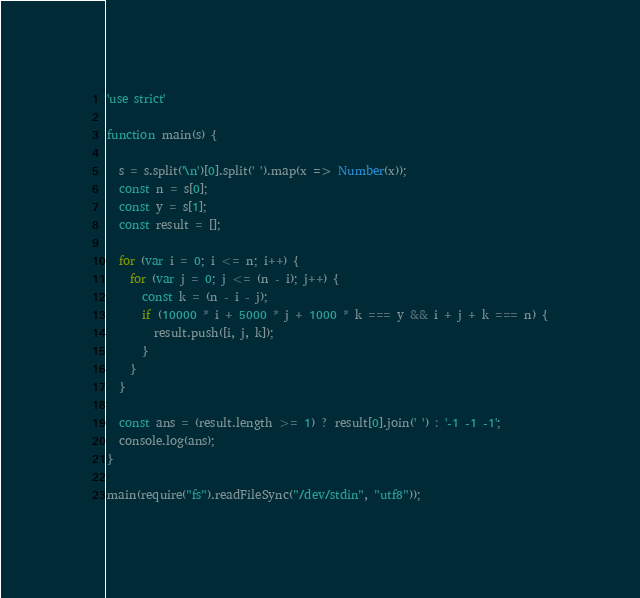<code> <loc_0><loc_0><loc_500><loc_500><_JavaScript_>'use strict'

function main(s) {

  s = s.split('\n')[0].split(' ').map(x => Number(x));
  const n = s[0];
  const y = s[1];
  const result = [];

  for (var i = 0; i <= n; i++) {
    for (var j = 0; j <= (n - i); j++) {
      const k = (n - i - j);
      if (10000 * i + 5000 * j + 1000 * k === y && i + j + k === n) {
        result.push([i, j, k]);
      }
    }
  }

  const ans = (result.length >= 1) ? result[0].join(' ') : '-1 -1 -1';
  console.log(ans);
}

main(require("fs").readFileSync("/dev/stdin", "utf8"));
</code> 